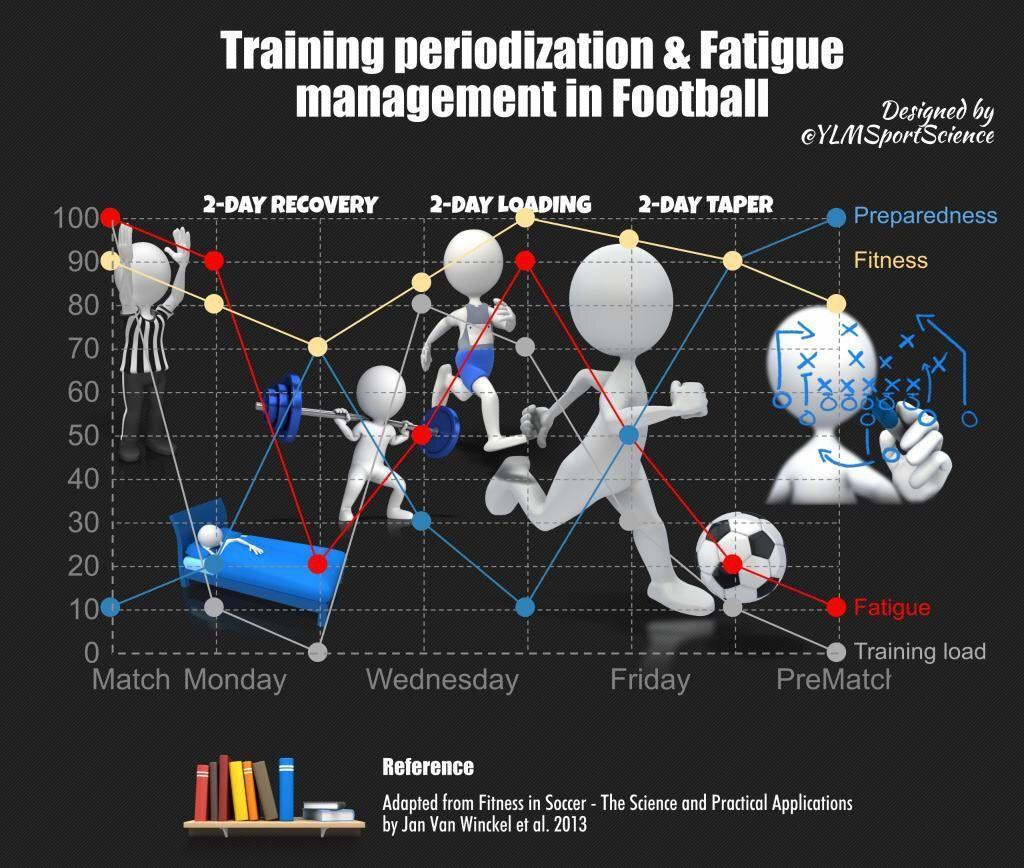Which three aspects of training & fatigue management would be at its  highest values on the day of the match?
Answer the question with a short phrase. Fitness, Fatigue, Training Load What should be at its lowest during pre-match, preparedness, fatigue, or training load? ? training load Which two aspects of training & fatigue management should be at its highest levels during pre-match? Preparedness, Fitness When does fatigue reach its highest point on Wednesday, Thursday, or Friday? Thursday Which day has the lowest level of training, Monday, Tuesday or Thursday? Tuesday Which aspect of training & fatigue management should be the lowest on the day of the match? Preparedness 